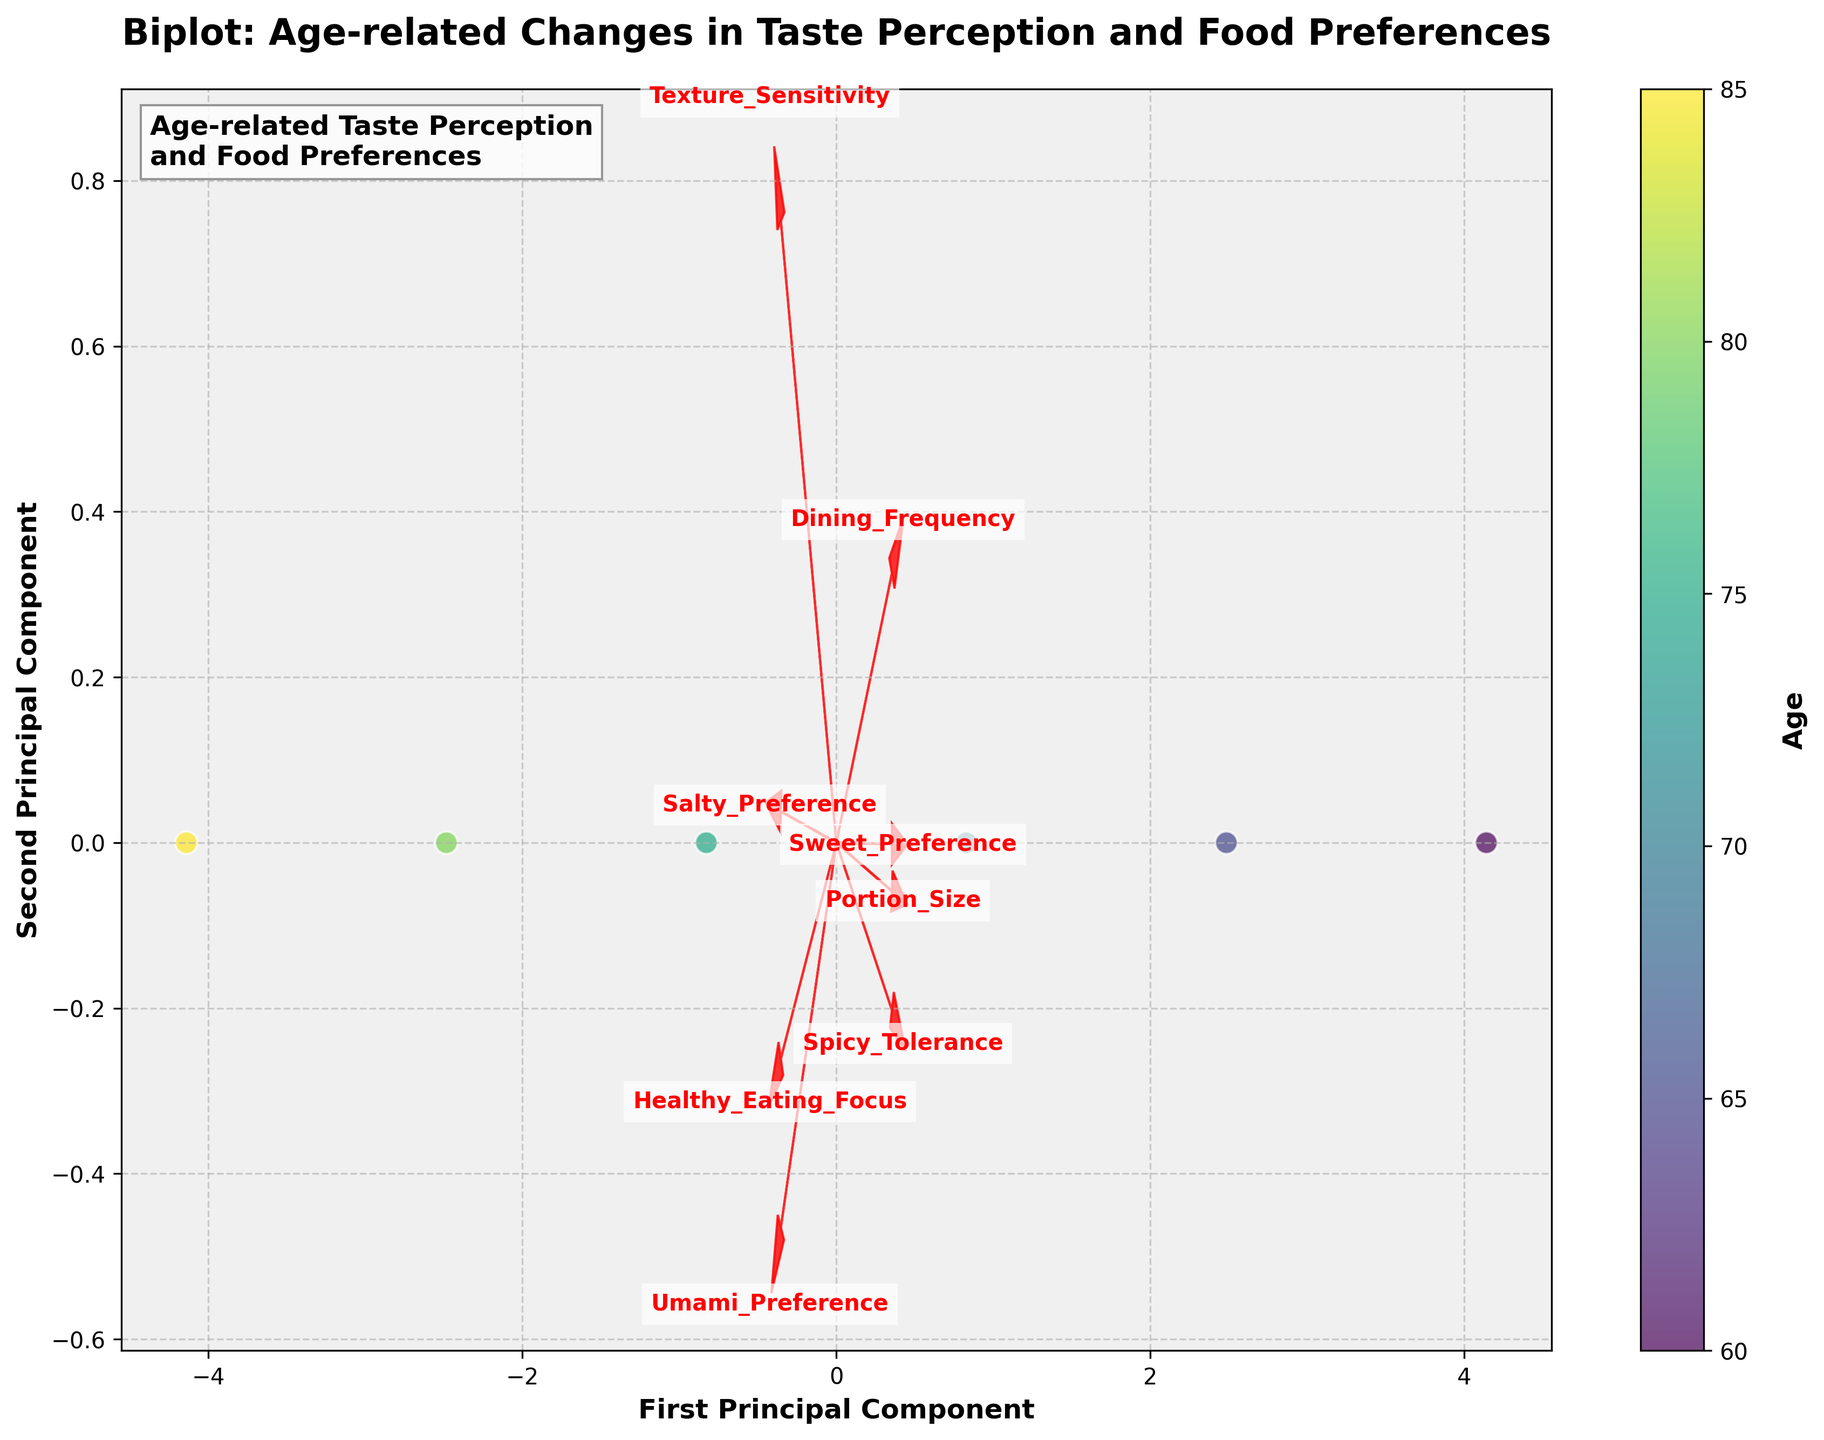What is the title of the plot? The title of the plot is prominently displayed at the top of the figure.
Answer: "Biplot: Age-related Changes in Taste Perception and Food Preferences" How many data points are represented in the plot? By counting each scattered point in the figure, you can see there are six distinct data points corresponding to different ages.
Answer: 6 What do the arrows in the plot represent? The arrows are vectors showing the direction and magnitude of the original features in the data, such as Sweet Preference, Salty Preference, etc.
Answer: Feature vectors Which feature has the strongest relationship with the first principal component? By looking at the length of the arrows on the x-axis, Umami Preference has the longest arrow in the direction of the first principal component.
Answer: Umami Preference As age increases, what happens to the Sweet Preference and Umami Preference? Observing the scatter plot and feature vectors, as the age increases, the Sweet Preference decreases and the Umami Preference increases.
Answer: Sweet Preference decreases, Umami Preference increases Which age group tends to focus more on healthy eating according to the colorbar? The color on the scatter plot indicates age, with the intensity increasing with age. The point with the deepest color represents the age 85 group, who focus more on healthy eating.
Answer: Age 85 How are texture sensitivity and spicy tolerance related based on the biplot? The feature vectors for texture sensitivity and spicy tolerance are pointing in similar, but slightly different, directions. This implies a positive correlation but not a perfect one.
Answer: Positively correlated Compare the dining frequency of the ages represented in the plot. From the color gradient and data point positions, younger ages (60-85) have data points with higher values along the axis indicating dining frequency, which tends to decrease with age.
Answer: Dining frequency decreases with age What pattern do you observe between portion size and age? Analyzing the arrows, the portion size decreases consistently as age increases, shown by the vector pointing in the negative direction with respect to age.
Answer: Portion size decreases with age 